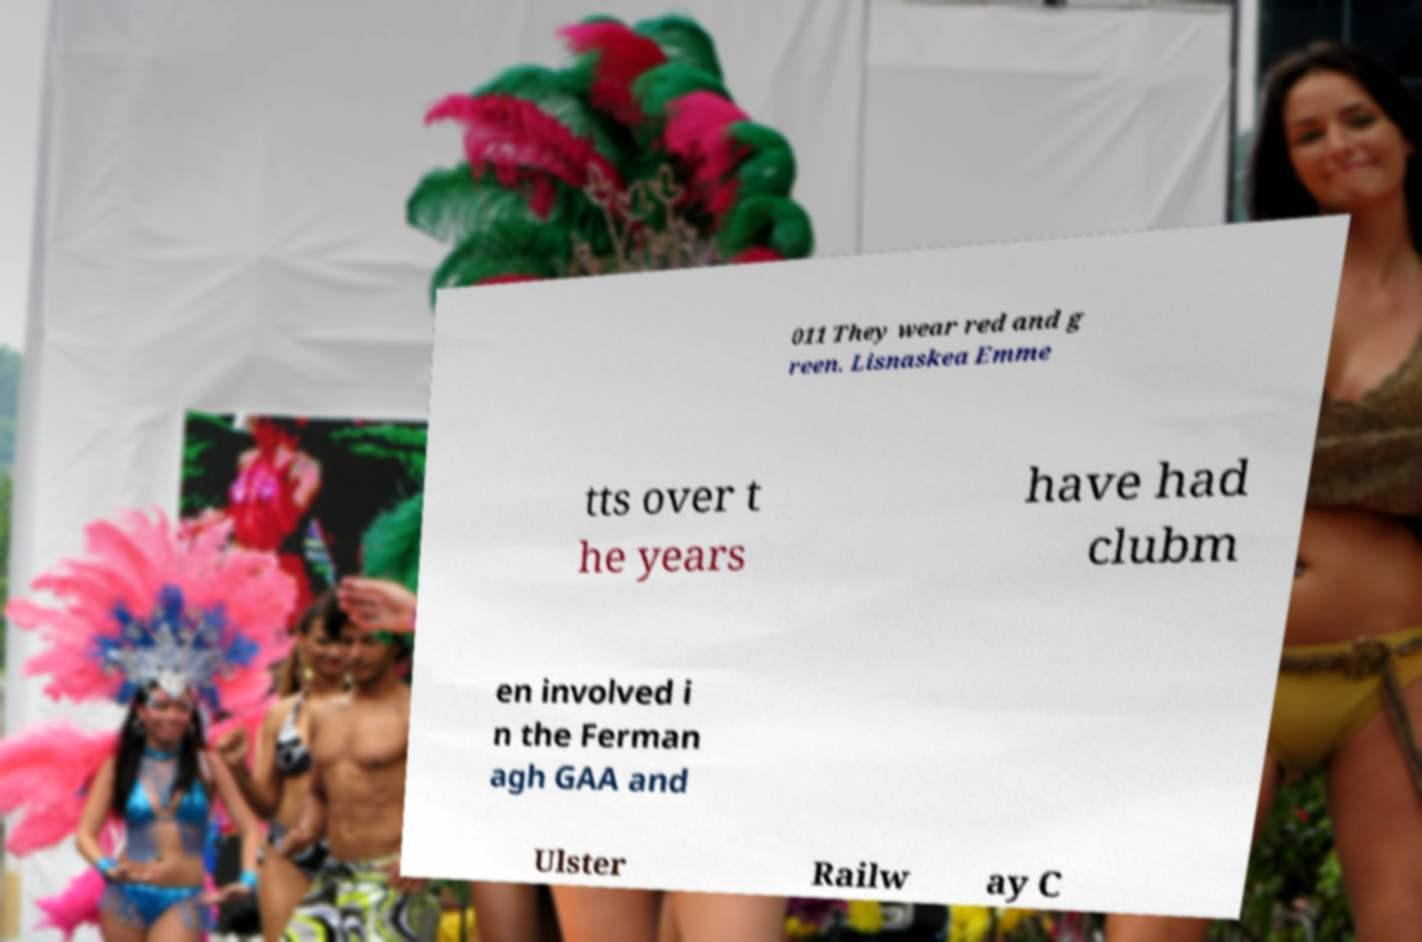I need the written content from this picture converted into text. Can you do that? 011 They wear red and g reen. Lisnaskea Emme tts over t he years have had clubm en involved i n the Ferman agh GAA and Ulster Railw ay C 